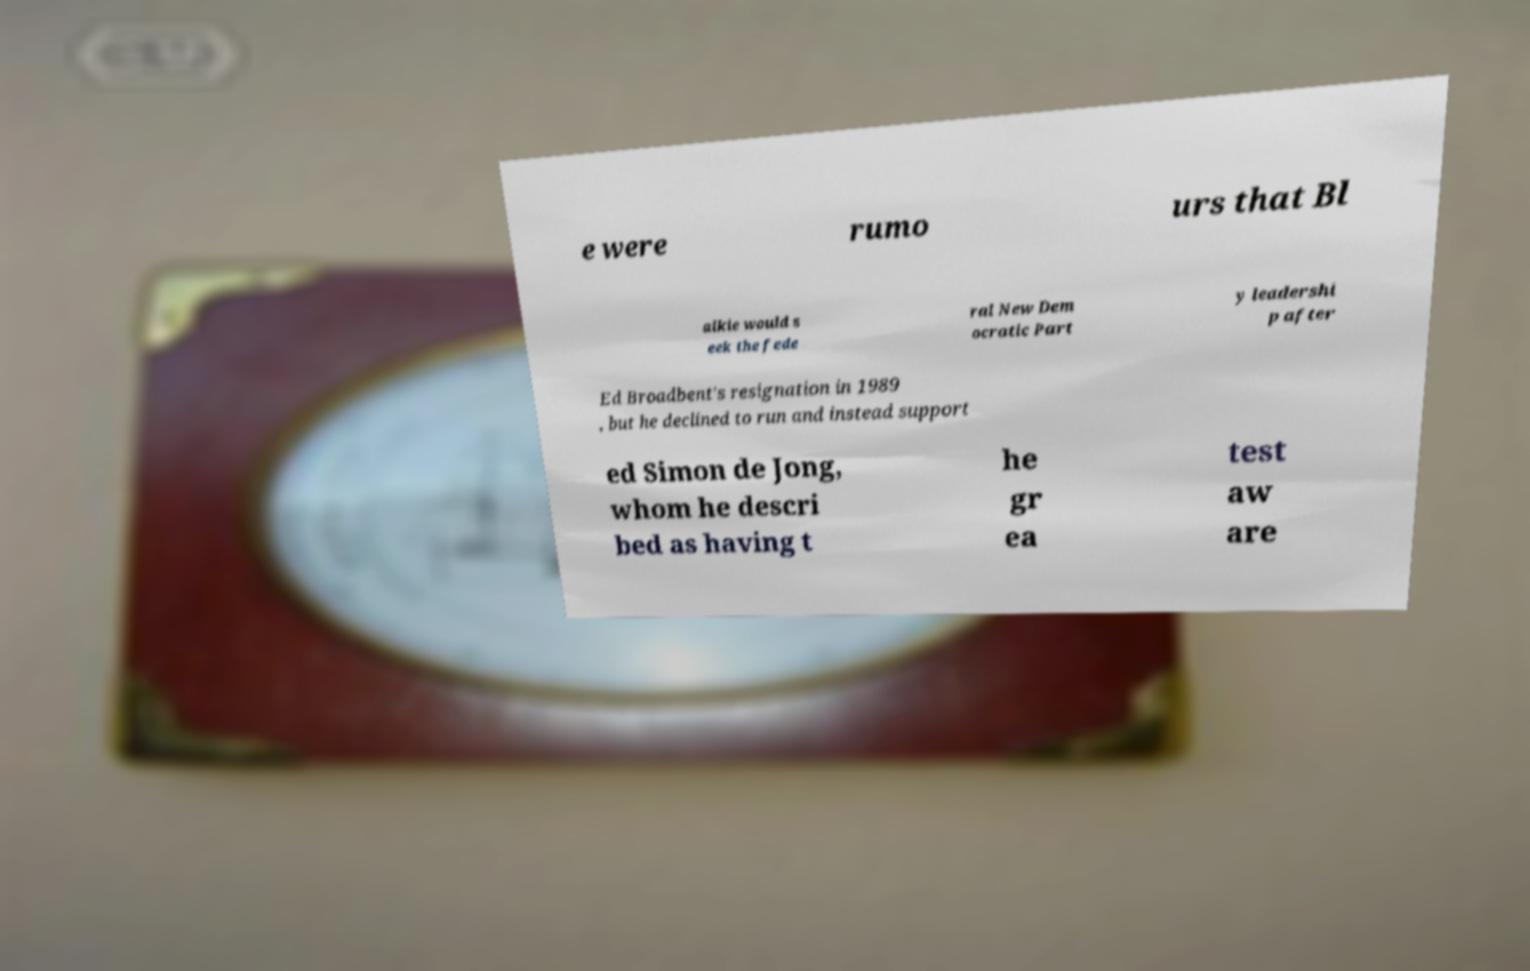Could you extract and type out the text from this image? e were rumo urs that Bl aikie would s eek the fede ral New Dem ocratic Part y leadershi p after Ed Broadbent's resignation in 1989 , but he declined to run and instead support ed Simon de Jong, whom he descri bed as having t he gr ea test aw are 